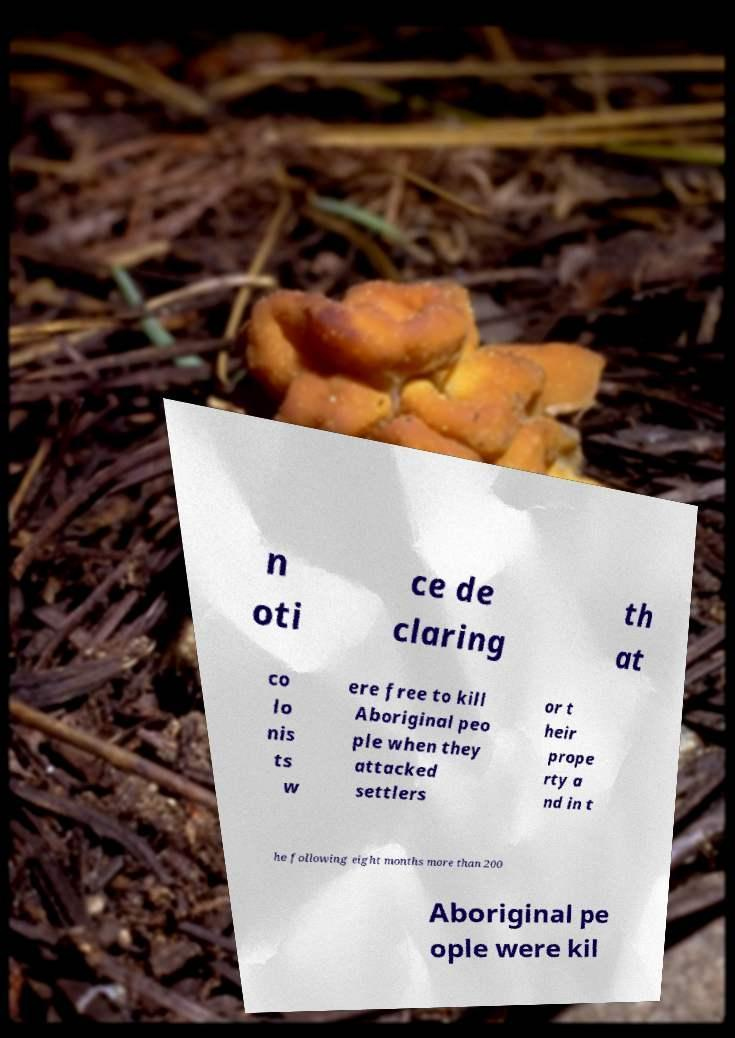For documentation purposes, I need the text within this image transcribed. Could you provide that? n oti ce de claring th at co lo nis ts w ere free to kill Aboriginal peo ple when they attacked settlers or t heir prope rty a nd in t he following eight months more than 200 Aboriginal pe ople were kil 